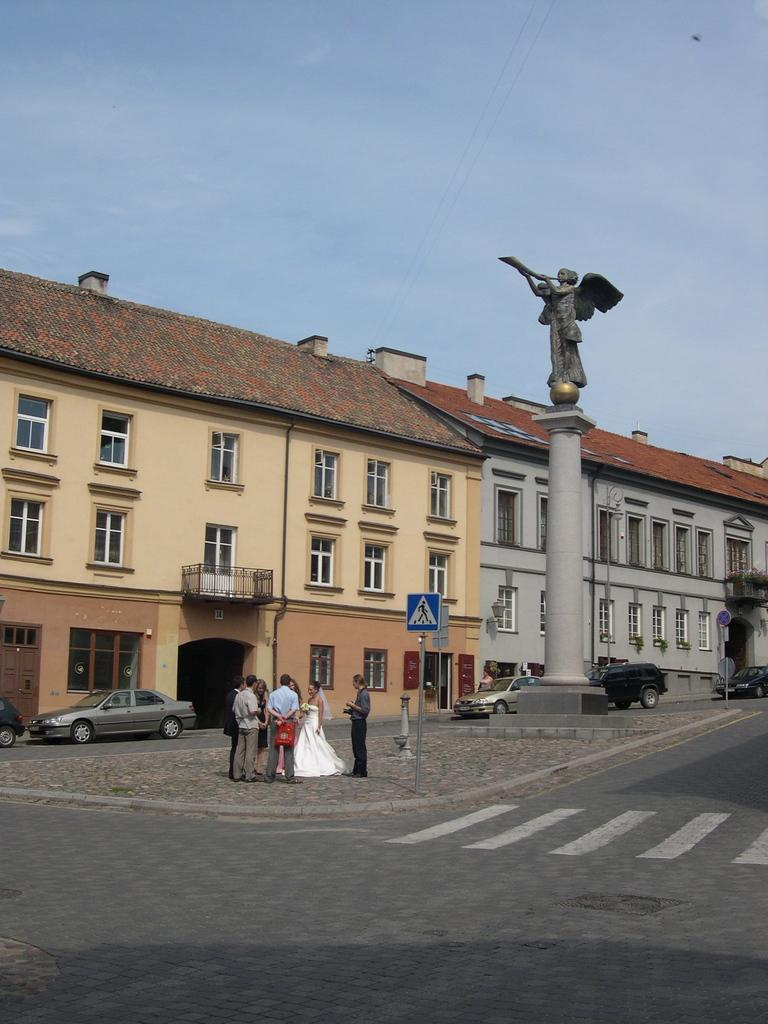What type of structure is visible in the image? There is a building in the image. What can be seen in front of the building? There are cars in front of the building. What is on top of the pole in the image? There is a sculpture on top of the pole in the image. Can you describe the people in the image? There are people standing in a group in the image. How many legs can be seen on the ants in the image? There are no ants present in the image, so it is not possible to determine the number of legs on any ants. 